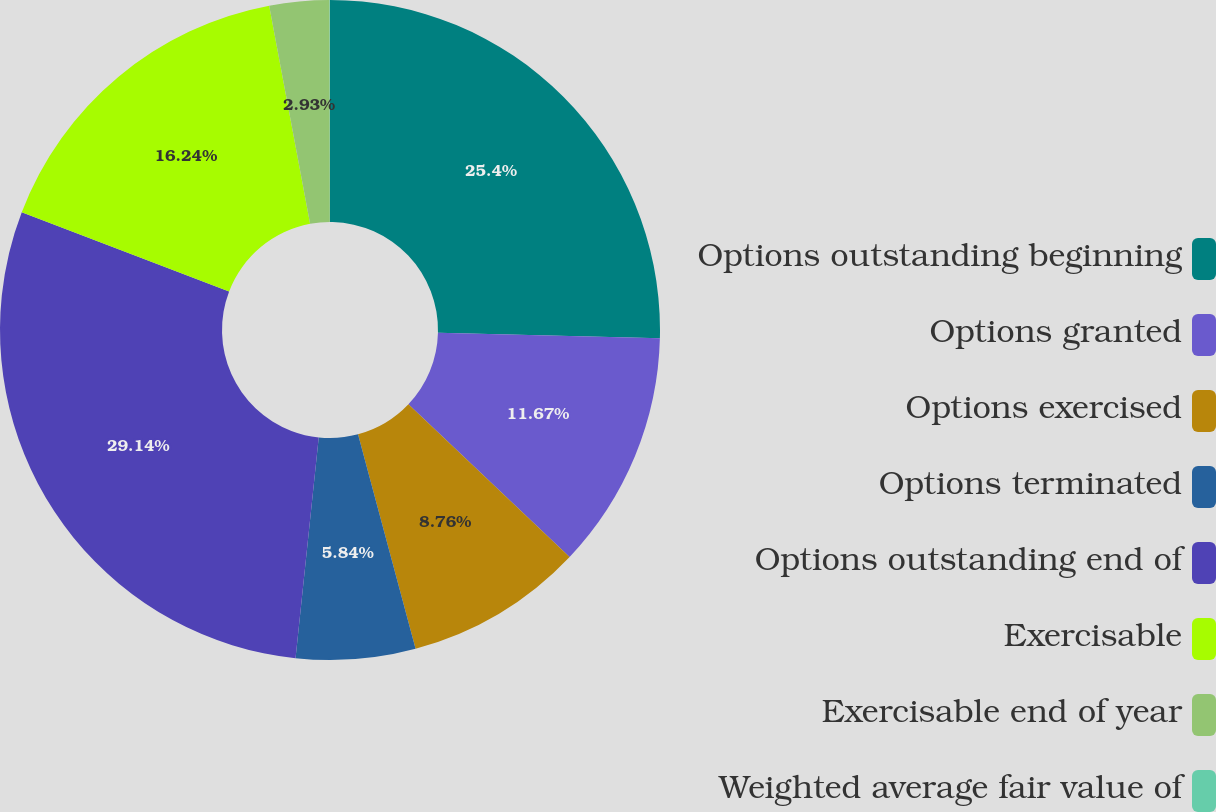Convert chart to OTSL. <chart><loc_0><loc_0><loc_500><loc_500><pie_chart><fcel>Options outstanding beginning<fcel>Options granted<fcel>Options exercised<fcel>Options terminated<fcel>Options outstanding end of<fcel>Exercisable<fcel>Exercisable end of year<fcel>Weighted average fair value of<nl><fcel>25.4%<fcel>11.67%<fcel>8.76%<fcel>5.84%<fcel>29.15%<fcel>16.24%<fcel>2.93%<fcel>0.02%<nl></chart> 